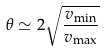<formula> <loc_0><loc_0><loc_500><loc_500>\theta \simeq 2 \sqrt { \frac { v _ { \min } } { v _ { \max } } }</formula> 